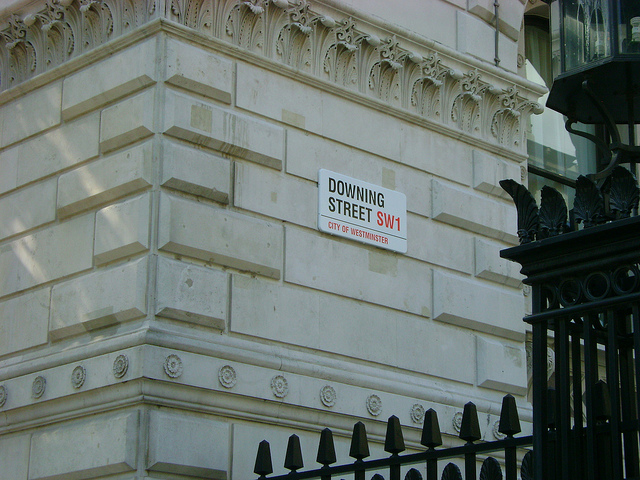<image>What season is depicted in this photo? I am not sure what season is depicted in the photo. It can be summer, spring, or fall. What season is depicted in this photo? I don't know what season is depicted in the photo. It can be seen 'summer', 'november', 'spring' or 'fall'. 